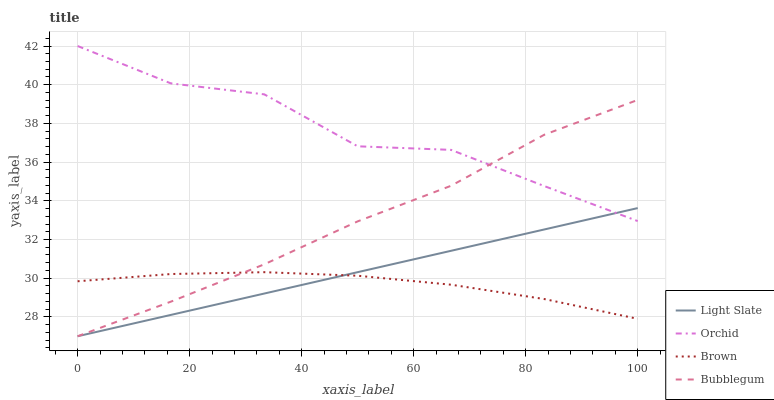Does Brown have the minimum area under the curve?
Answer yes or no. Yes. Does Orchid have the maximum area under the curve?
Answer yes or no. Yes. Does Bubblegum have the minimum area under the curve?
Answer yes or no. No. Does Bubblegum have the maximum area under the curve?
Answer yes or no. No. Is Light Slate the smoothest?
Answer yes or no. Yes. Is Orchid the roughest?
Answer yes or no. Yes. Is Brown the smoothest?
Answer yes or no. No. Is Brown the roughest?
Answer yes or no. No. Does Light Slate have the lowest value?
Answer yes or no. Yes. Does Brown have the lowest value?
Answer yes or no. No. Does Orchid have the highest value?
Answer yes or no. Yes. Does Bubblegum have the highest value?
Answer yes or no. No. Is Brown less than Orchid?
Answer yes or no. Yes. Is Orchid greater than Brown?
Answer yes or no. Yes. Does Orchid intersect Bubblegum?
Answer yes or no. Yes. Is Orchid less than Bubblegum?
Answer yes or no. No. Is Orchid greater than Bubblegum?
Answer yes or no. No. Does Brown intersect Orchid?
Answer yes or no. No. 